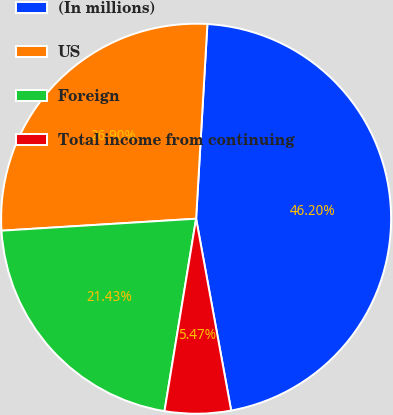Convert chart to OTSL. <chart><loc_0><loc_0><loc_500><loc_500><pie_chart><fcel>(In millions)<fcel>US<fcel>Foreign<fcel>Total income from continuing<nl><fcel>46.2%<fcel>26.9%<fcel>21.43%<fcel>5.47%<nl></chart> 